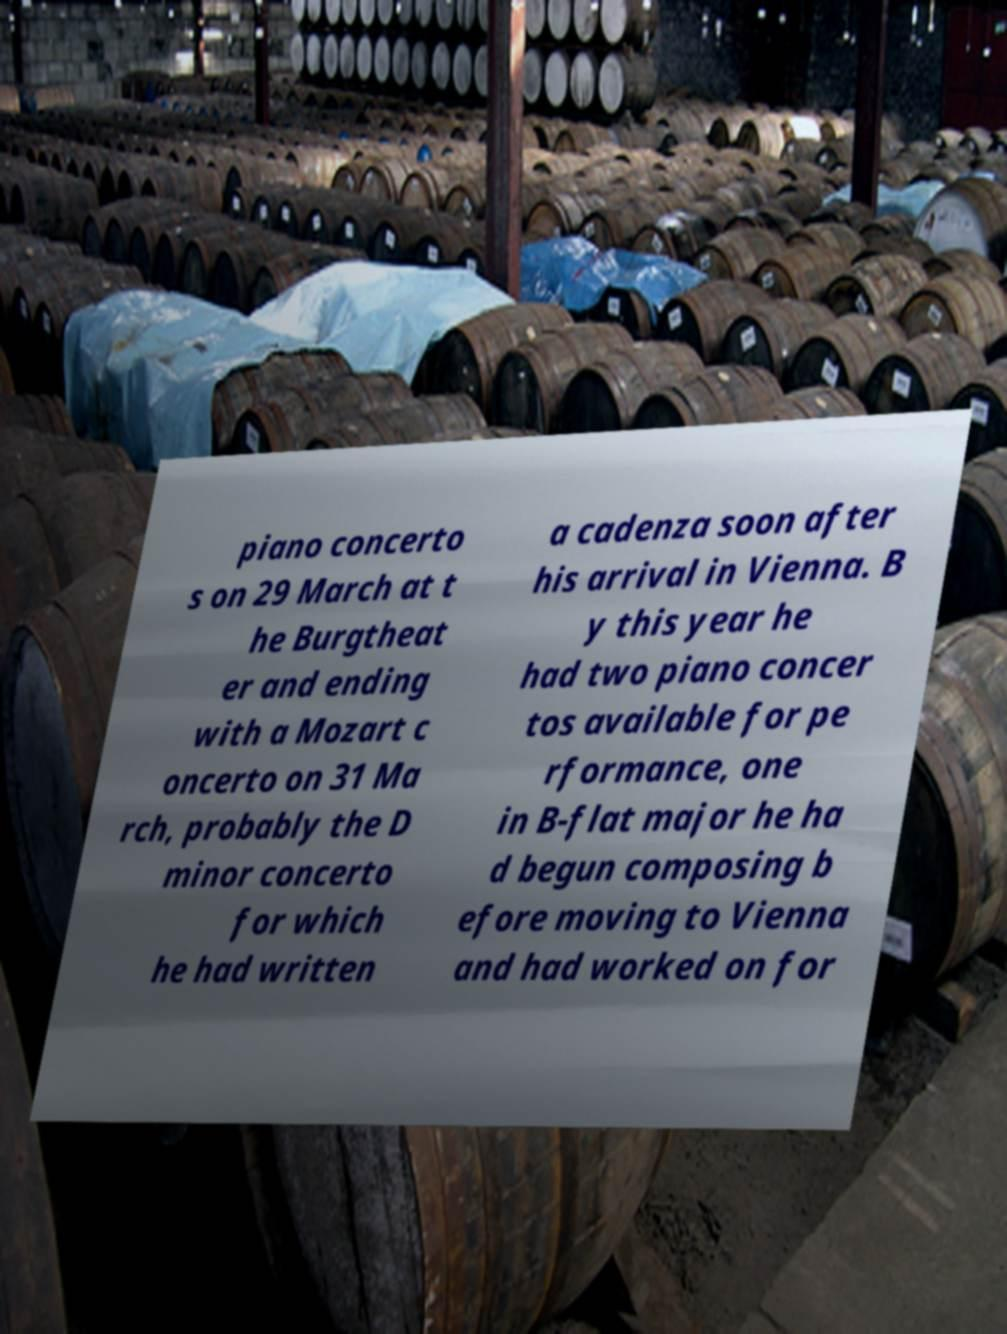There's text embedded in this image that I need extracted. Can you transcribe it verbatim? piano concerto s on 29 March at t he Burgtheat er and ending with a Mozart c oncerto on 31 Ma rch, probably the D minor concerto for which he had written a cadenza soon after his arrival in Vienna. B y this year he had two piano concer tos available for pe rformance, one in B-flat major he ha d begun composing b efore moving to Vienna and had worked on for 